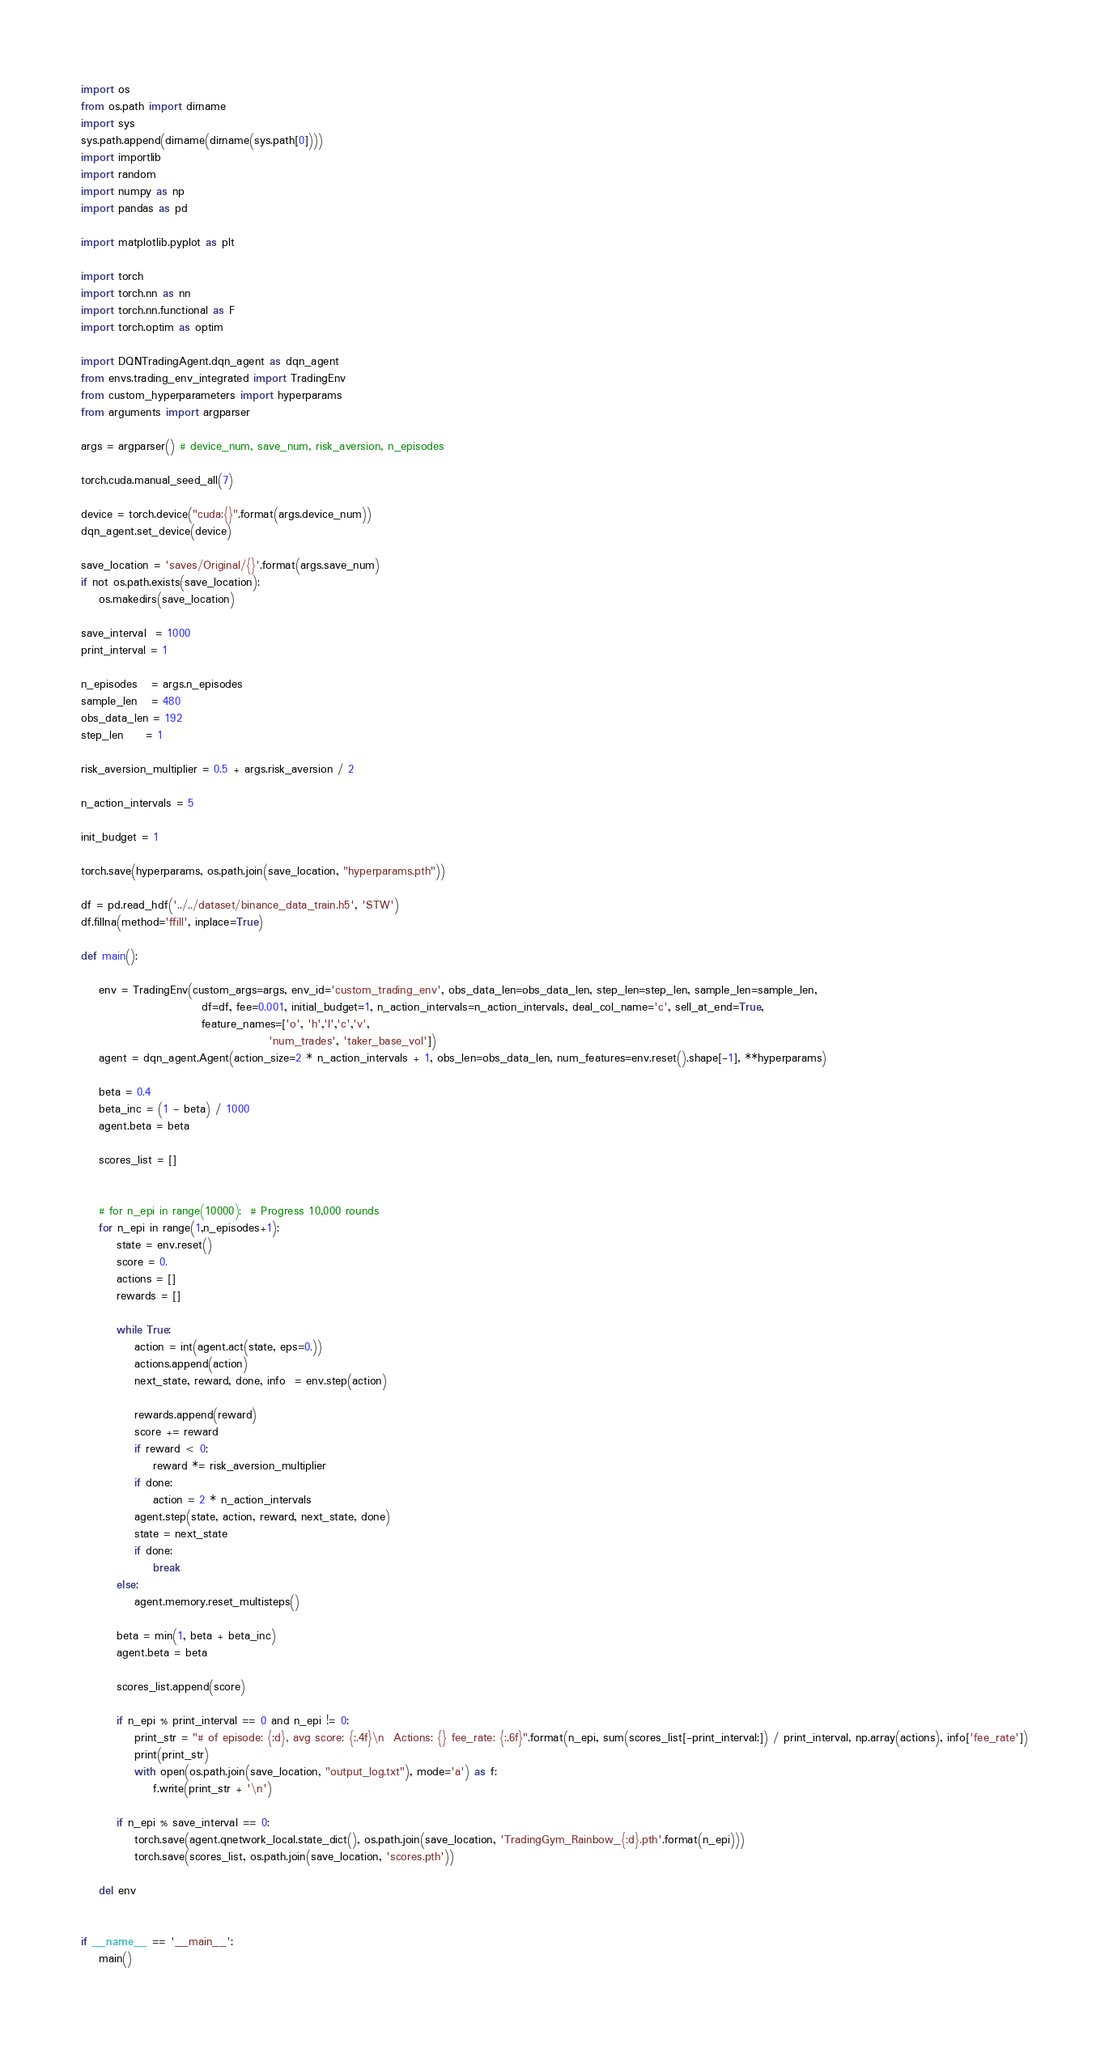Convert code to text. <code><loc_0><loc_0><loc_500><loc_500><_Python_>import os
from os.path import dirname
import sys
sys.path.append(dirname(dirname(sys.path[0])))
import importlib
import random
import numpy as np
import pandas as pd

import matplotlib.pyplot as plt

import torch
import torch.nn as nn
import torch.nn.functional as F
import torch.optim as optim

import DQNTradingAgent.dqn_agent as dqn_agent
from envs.trading_env_integrated import TradingEnv
from custom_hyperparameters import hyperparams
from arguments import argparser

args = argparser() # device_num, save_num, risk_aversion, n_episodes

torch.cuda.manual_seed_all(7)

device = torch.device("cuda:{}".format(args.device_num))
dqn_agent.set_device(device)

save_location = 'saves/Original/{}'.format(args.save_num)
if not os.path.exists(save_location):
    os.makedirs(save_location)

save_interval  = 1000
print_interval = 1

n_episodes   = args.n_episodes
sample_len   = 480
obs_data_len = 192
step_len     = 1

risk_aversion_multiplier = 0.5 + args.risk_aversion / 2

n_action_intervals = 5

init_budget = 1

torch.save(hyperparams, os.path.join(save_location, "hyperparams.pth"))

df = pd.read_hdf('../../dataset/binance_data_train.h5', 'STW')
df.fillna(method='ffill', inplace=True)

def main():

    env = TradingEnv(custom_args=args, env_id='custom_trading_env', obs_data_len=obs_data_len, step_len=step_len, sample_len=sample_len,
                           df=df, fee=0.001, initial_budget=1, n_action_intervals=n_action_intervals, deal_col_name='c', sell_at_end=True,
                           feature_names=['o', 'h','l','c','v',
                                          'num_trades', 'taker_base_vol'])
    agent = dqn_agent.Agent(action_size=2 * n_action_intervals + 1, obs_len=obs_data_len, num_features=env.reset().shape[-1], **hyperparams)

    beta = 0.4
    beta_inc = (1 - beta) / 1000
    agent.beta = beta

    scores_list = []
    
    
    # for n_epi in range(10000):  # Progress 10,000 rounds 
    for n_epi in range(1,n_episodes+1):
        state = env.reset()
        score = 0.
        actions = []
        rewards = []

        while True:
            action = int(agent.act(state, eps=0.))
            actions.append(action)
            next_state, reward, done, info  = env.step(action)

            rewards.append(reward)
            score += reward
            if reward < 0:
                reward *= risk_aversion_multiplier
            if done:
                action = 2 * n_action_intervals
            agent.step(state, action, reward, next_state, done)
            state = next_state
            if done:
                break
        else:
            agent.memory.reset_multisteps()

        beta = min(1, beta + beta_inc)
        agent.beta = beta

        scores_list.append(score)

        if n_epi % print_interval == 0 and n_epi != 0:
            print_str = "# of episode: {:d}, avg score: {:.4f}\n  Actions: {} fee_rate: {:.6f}".format(n_epi, sum(scores_list[-print_interval:]) / print_interval, np.array(actions), info['fee_rate'])
            print(print_str)
            with open(os.path.join(save_location, "output_log.txt"), mode='a') as f:
                f.write(print_str + '\n')

        if n_epi % save_interval == 0:
            torch.save(agent.qnetwork_local.state_dict(), os.path.join(save_location, 'TradingGym_Rainbow_{:d}.pth'.format(n_epi)))
            torch.save(scores_list, os.path.join(save_location, 'scores.pth'))

    del env


if __name__ == '__main__':
    main()
</code> 